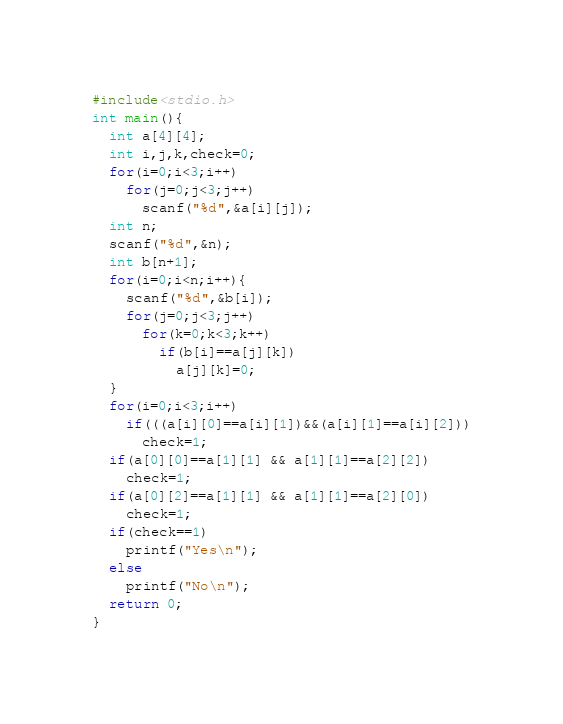Convert code to text. <code><loc_0><loc_0><loc_500><loc_500><_C_>#include<stdio.h>
int main(){
  int a[4][4];
  int i,j,k,check=0;
  for(i=0;i<3;i++)
    for(j=0;j<3;j++)
      scanf("%d",&a[i][j]);
  int n;
  scanf("%d",&n);
  int b[n+1];
  for(i=0;i<n;i++){
    scanf("%d",&b[i]);
    for(j=0;j<3;j++)
      for(k=0;k<3;k++)
        if(b[i]==a[j][k])
          a[j][k]=0;
  }
  for(i=0;i<3;i++)
    if(((a[i][0]==a[i][1])&&(a[i][1]==a[i][2]))
      check=1;
  if(a[0][0]==a[1][1] && a[1][1]==a[2][2])
    check=1;
  if(a[0][2]==a[1][1] && a[1][1]==a[2][0])
    check=1;
  if(check==1)
    printf("Yes\n");
  else
    printf("No\n");
  return 0;
}</code> 